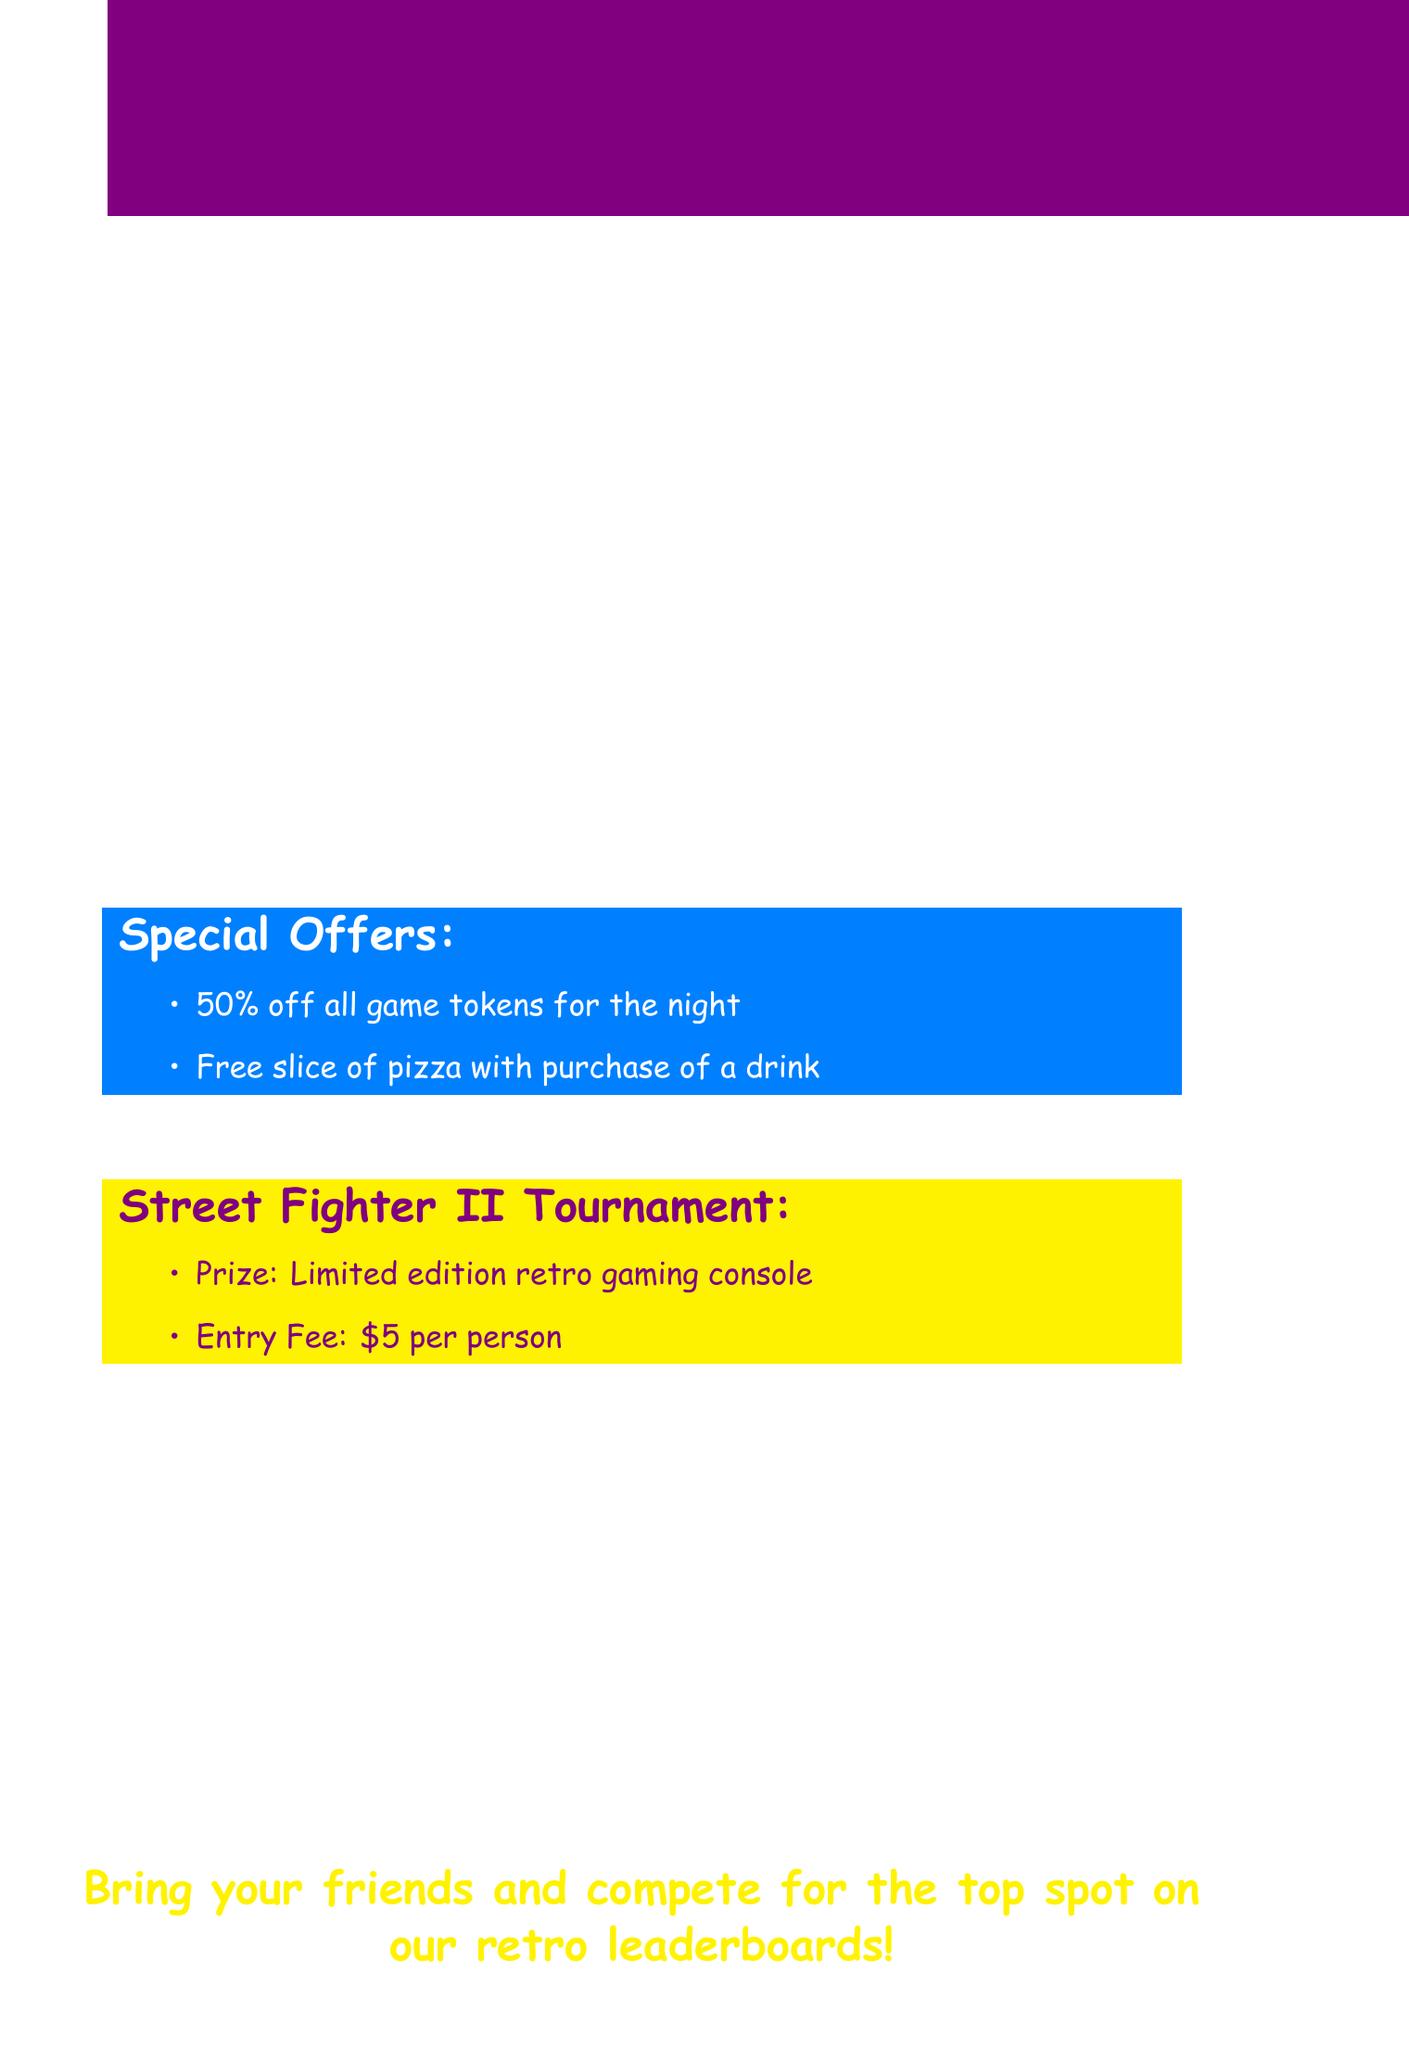What is the event date? The event date is specified in the document as Saturday, August 12th.
Answer: Saturday, August 12th What time does the event start and end? The starting and ending times are mentioned together in the document.
Answer: 7 PM - Midnight Where is the event located? The location of the event is provided in the document.
Answer: Pixel Palace Arcade, 123 Main Street What is the entry fee for the tournament? The entry fee amount is detailed in the tournament information section of the document.
Answer: $5 per person What is the prize for the Street Fighter II tournament? The prize for the tournament is mentioned specifically in the document.
Answer: Limited edition retro gaming console What special offer is available with the purchase of a drink? The document states a specific offer related to drink purchases.
Answer: Free slice of pizza What is the dress code for the event? The dress code is explicitly mentioned in the additional info section.
Answer: 80s/90s themed costumes encouraged (optional) What is the RSVP deadline? The deadline for RSVP is specified towards the end of the document.
Answer: August 10th What is the age restriction for the event? The age restriction is clearly stated in the document.
Answer: Open to all ages, 16 and under must be accompanied by an adult 